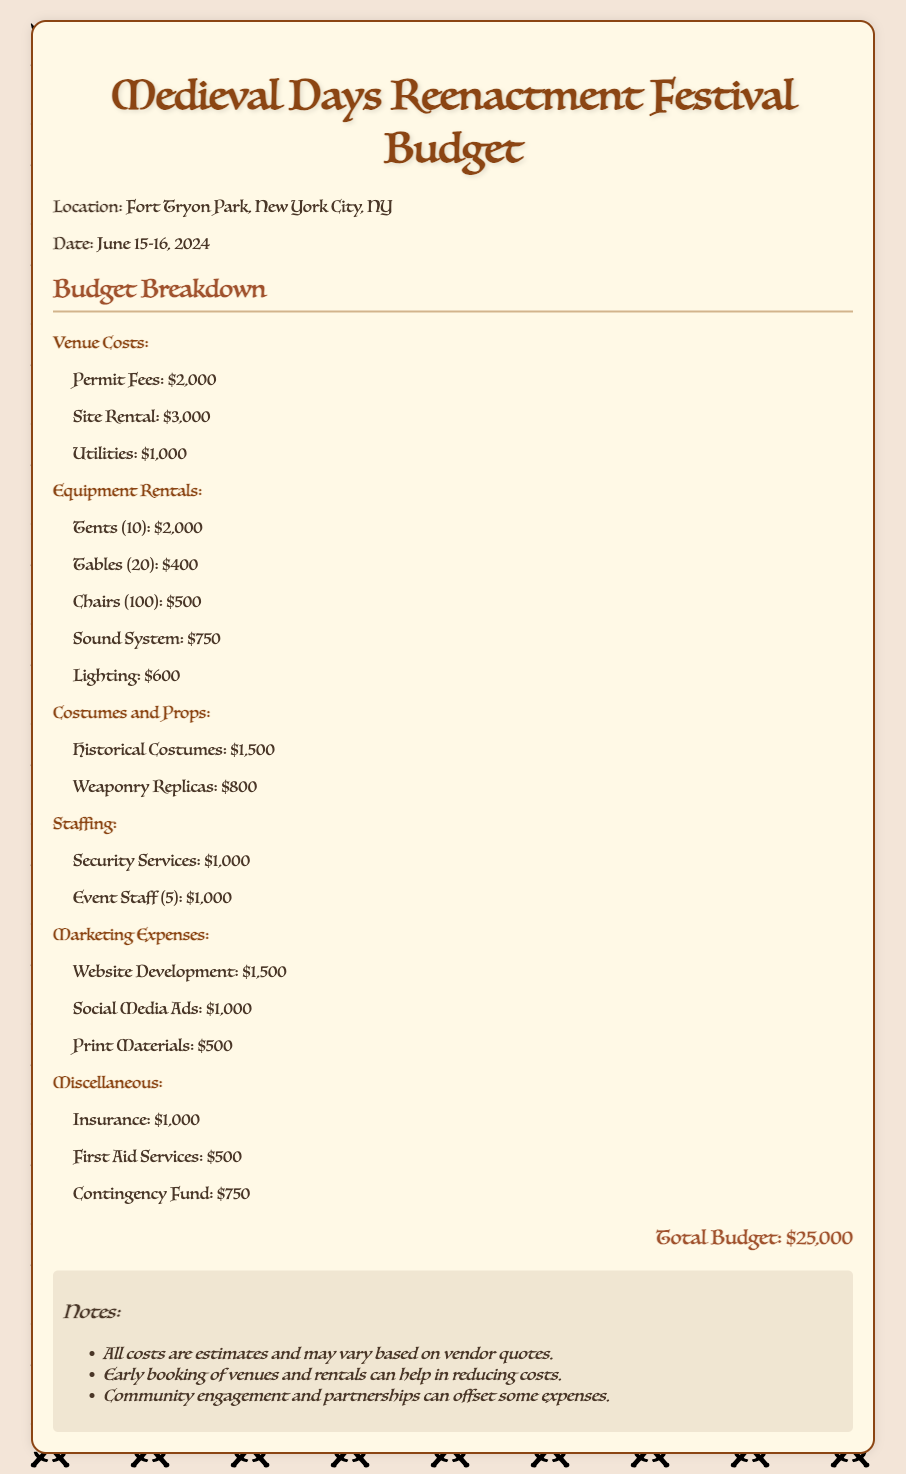What is the location of the festival? The document states that the location is Fort Tryon Park, New York City, NY.
Answer: Fort Tryon Park, New York City, NY What is the date of the Medieval Days Reenactment Festival? The date is mentioned in the document as June 15-16, 2024.
Answer: June 15-16, 2024 How much is allocated for permit fees? The document specifies the permit fees as $2,000.
Answer: $2,000 What is the total budget for the festival? The total budget is summarized at the end of the document, totaling $25,000.
Answer: $25,000 What is the cost for the sound system rental? The sound system rental cost is listed as $750 in the document.
Answer: $750 How much is being spent on historical costumes? The document indicates that $1,500 is allocated for historical costumes.
Answer: $1,500 What category does the item 'First Aid Services' fall under? The document lists 'First Aid Services' under the Miscellaneous category.
Answer: Miscellaneous How many tables are being rented for the festival? The document states that 20 tables are rented for the event.
Answer: 20 What is the budget for marketing expenses? The budget for marketing expenses is detailed, totaling $3,000.
Answer: $3,000 